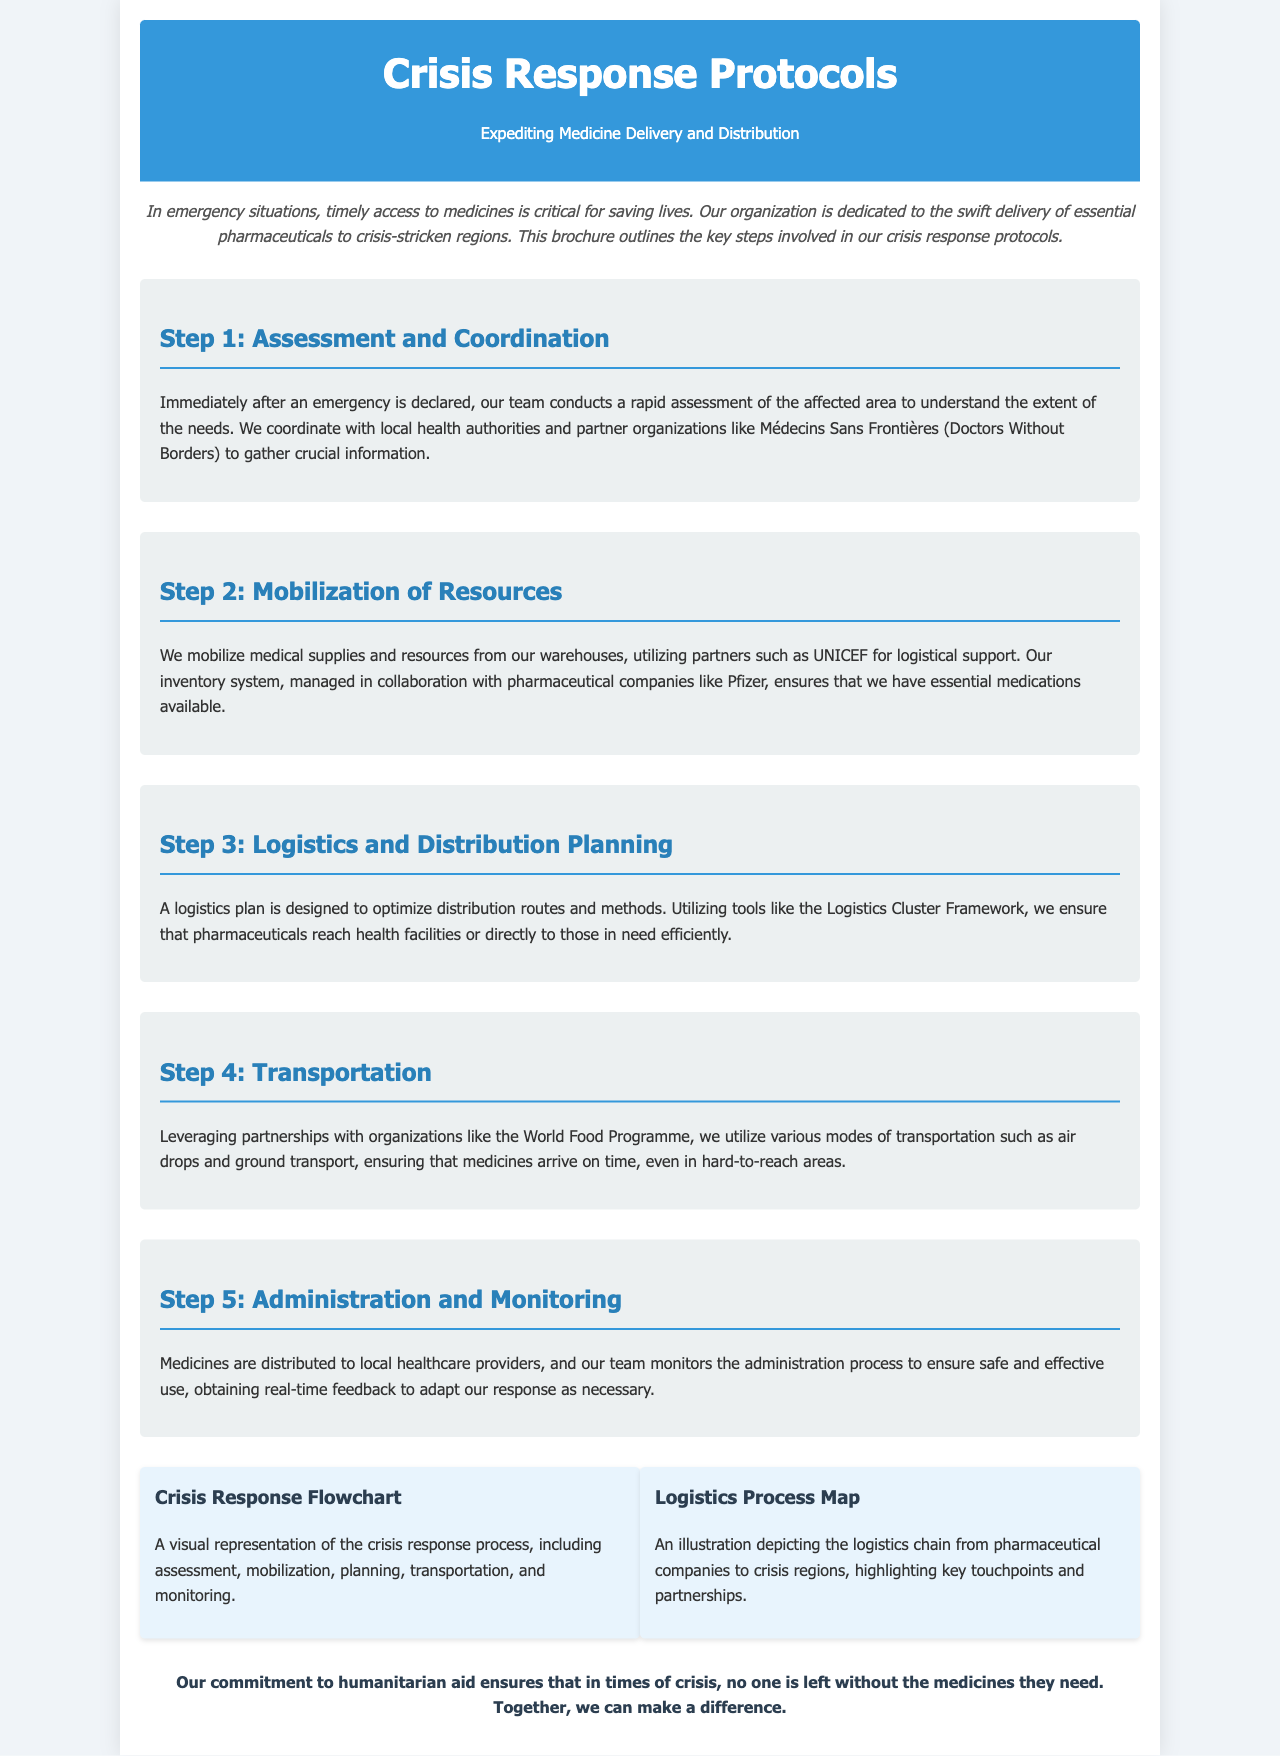What is the title of the brochure? The title is prominently displayed at the top of the document.
Answer: Crisis Response Protocols What organization does the brochure represent? The brochure describes the organization that administers medicines in crisis situations.
Answer: Humanitarian aid organization What is the first step in the crisis response protocols? The first step is outlined in the second section of the document.
Answer: Assessment and Coordination Which partner organization is mentioned for logistical support? The document references partners that aid in resource mobilization.
Answer: UNICEF What mode of transportation is specifically mentioned for delivering medicines? The brochure states various transportation methods used during crises.
Answer: Air drops How many steps are outlined in the crisis response protocols? The number of steps can be determined by counting the sections presented in the document.
Answer: Five What does the logistics process map illustrate? The details regarding the illustrations are provided in the diagram descriptions.
Answer: Logistics chain What is the purpose of the monitoring process in the crisis response? The role of monitoring is discussed in the last step of the process.
Answer: Safe and effective use What color is the background of the brochure? The background color is mentioned in the document's style description.
Answer: Light gray 